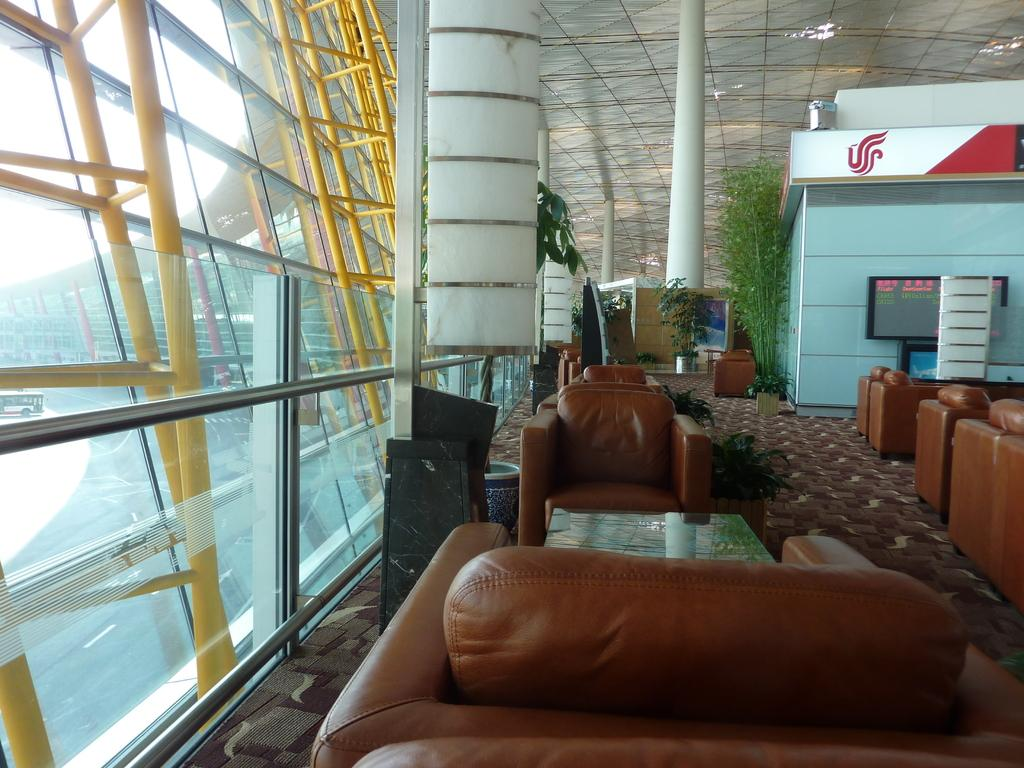What type of furniture is present in the image? There are chairs in the image. What type of living organisms can be seen in the image? There are plants in the image. What can be seen on the left side of the image? There are yellow rods on the left side of the image. What is the secretary doing in the image? There is no secretary present in the image. What is the chance of winning the lottery in the image? There is no reference to a lottery or any chances in the image. 